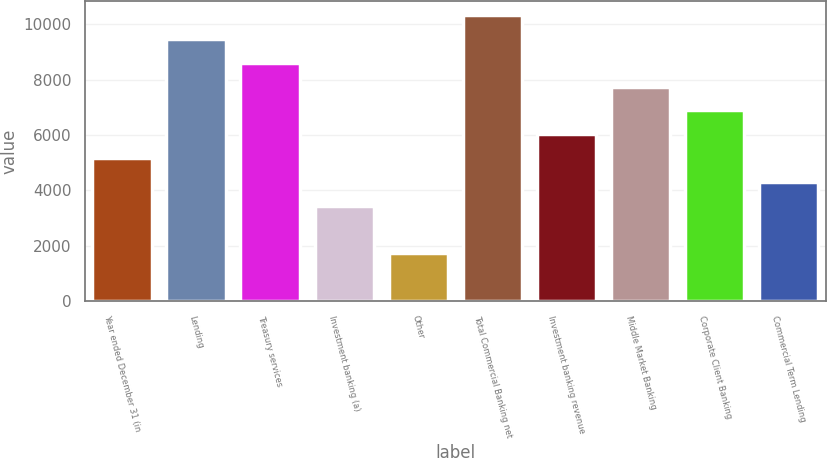Convert chart to OTSL. <chart><loc_0><loc_0><loc_500><loc_500><bar_chart><fcel>Year ended December 31 (in<fcel>Lending<fcel>Treasury services<fcel>Investment banking (a)<fcel>Other<fcel>Total Commercial Banking net<fcel>Investment banking revenue<fcel>Middle Market Banking<fcel>Corporate Client Banking<fcel>Commercial Term Lending<nl><fcel>5169.8<fcel>9463.8<fcel>8605<fcel>3452.2<fcel>1734.6<fcel>10322.6<fcel>6028.6<fcel>7746.2<fcel>6887.4<fcel>4311<nl></chart> 